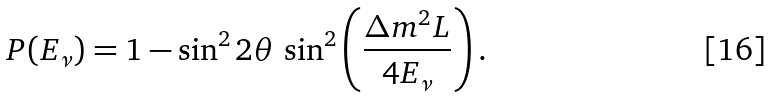Convert formula to latex. <formula><loc_0><loc_0><loc_500><loc_500>P ( E _ { \nu } ) = 1 - \sin ^ { 2 } 2 \theta \, \sin ^ { 2 } \left ( \frac { \Delta m ^ { 2 } L } { 4 E _ { \nu } } \right ) .</formula> 